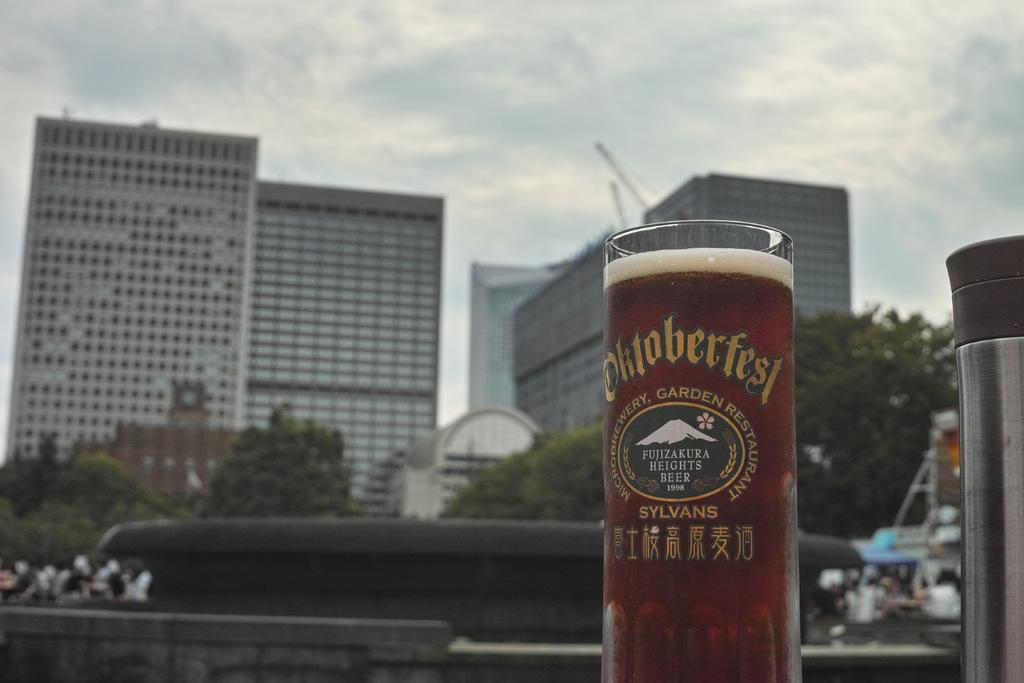<image>
Write a terse but informative summary of the picture. Full glass of Fujizakura Heights Beer 1998 with Oktoberfest Microbrewery, Garden Restaurant Sylvans etched on. 